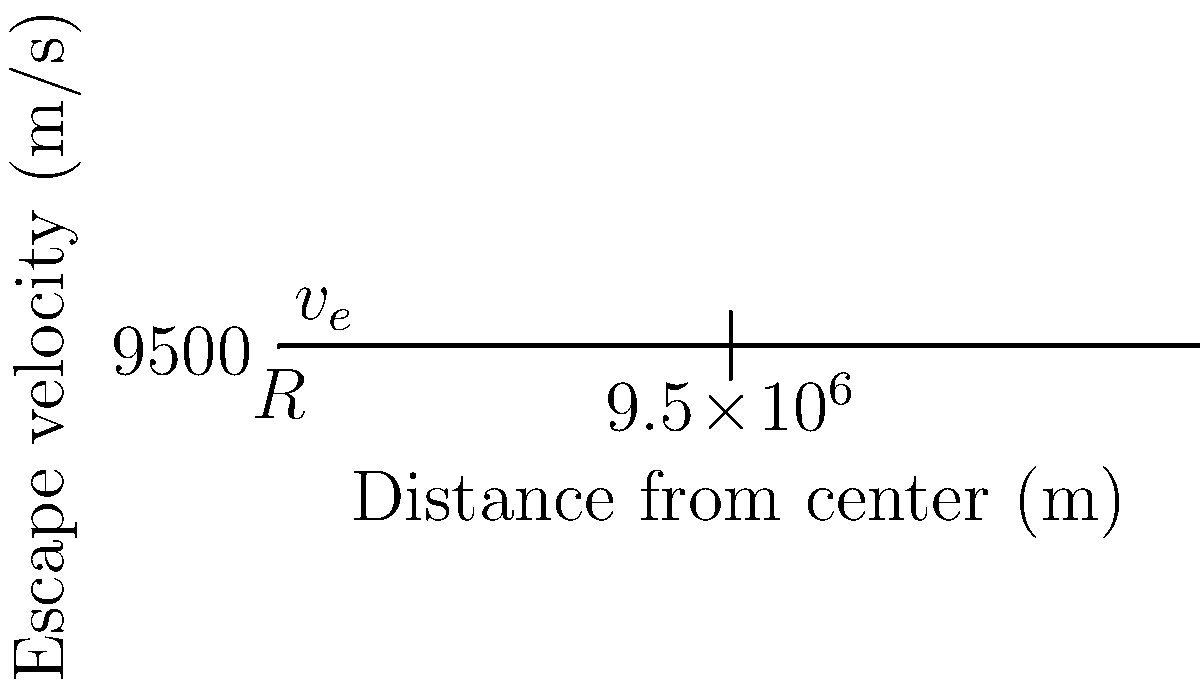Consider a planet with a mass of $5.97 \times 10^{24}$ kg and a radius of $6.37 \times 10^6$ m. Using the graph provided, which illustrates the relationship between escape velocity and distance from the planet's center, calculate the escape velocity from the surface of this planet. Give your answer in km/s, rounded to two decimal places. To solve this problem, we'll use the escape velocity formula and the given data:

1) The escape velocity formula is:
   $$v_e = \sqrt{\frac{2GM}{R}}$$
   where $G$ is the gravitational constant, $M$ is the mass of the planet, and $R$ is the radius of the planet.

2) We're given:
   $G = 6.67 \times 10^{-11}$ N⋅m²/kg²
   $M = 5.97 \times 10^{24}$ kg
   $R = 6.37 \times 10^6$ m

3) Let's substitute these values into the formula:
   $$v_e = \sqrt{\frac{2 \cdot (6.67 \times 10^{-11}) \cdot (5.97 \times 10^{24})}{6.37 \times 10^6}}$$

4) Simplify inside the square root:
   $$v_e = \sqrt{1.25 \times 10^8}$$

5) Calculate:
   $$v_e = 11,186 \text{ m/s}$$

6) Convert to km/s:
   $$v_e = 11.186 \text{ km/s}$$

7) Rounding to two decimal places:
   $$v_e = 11.19 \text{ km/s}$$

This result can be verified using the graph, where the escape velocity at the planet's surface (at distance $R$ from the center) is shown.
Answer: 11.19 km/s 